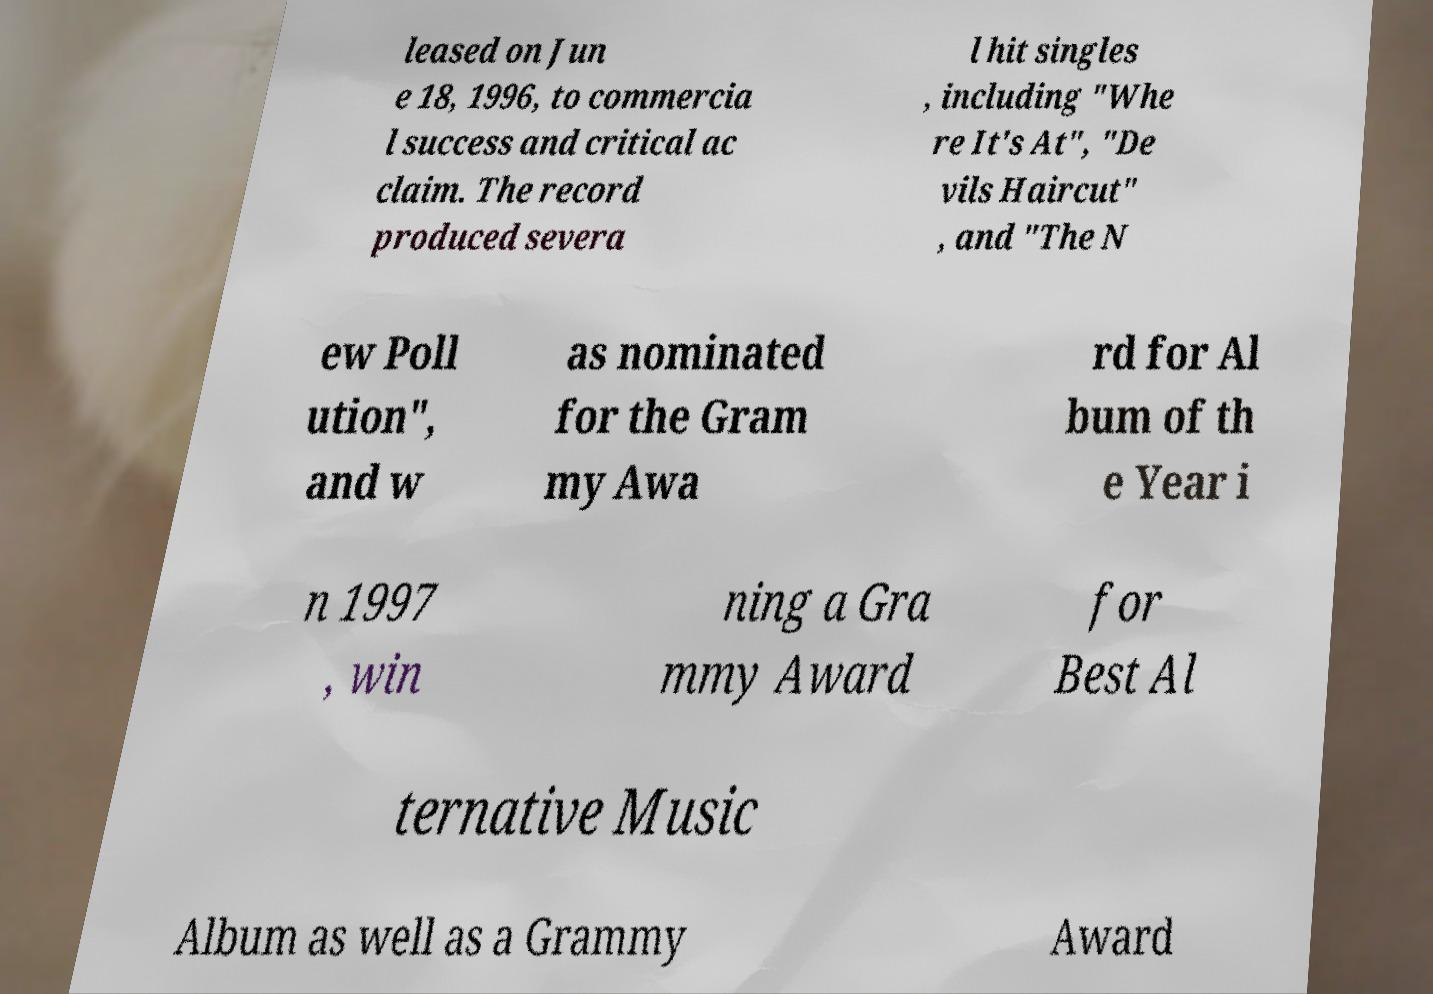I need the written content from this picture converted into text. Can you do that? leased on Jun e 18, 1996, to commercia l success and critical ac claim. The record produced severa l hit singles , including "Whe re It's At", "De vils Haircut" , and "The N ew Poll ution", and w as nominated for the Gram my Awa rd for Al bum of th e Year i n 1997 , win ning a Gra mmy Award for Best Al ternative Music Album as well as a Grammy Award 